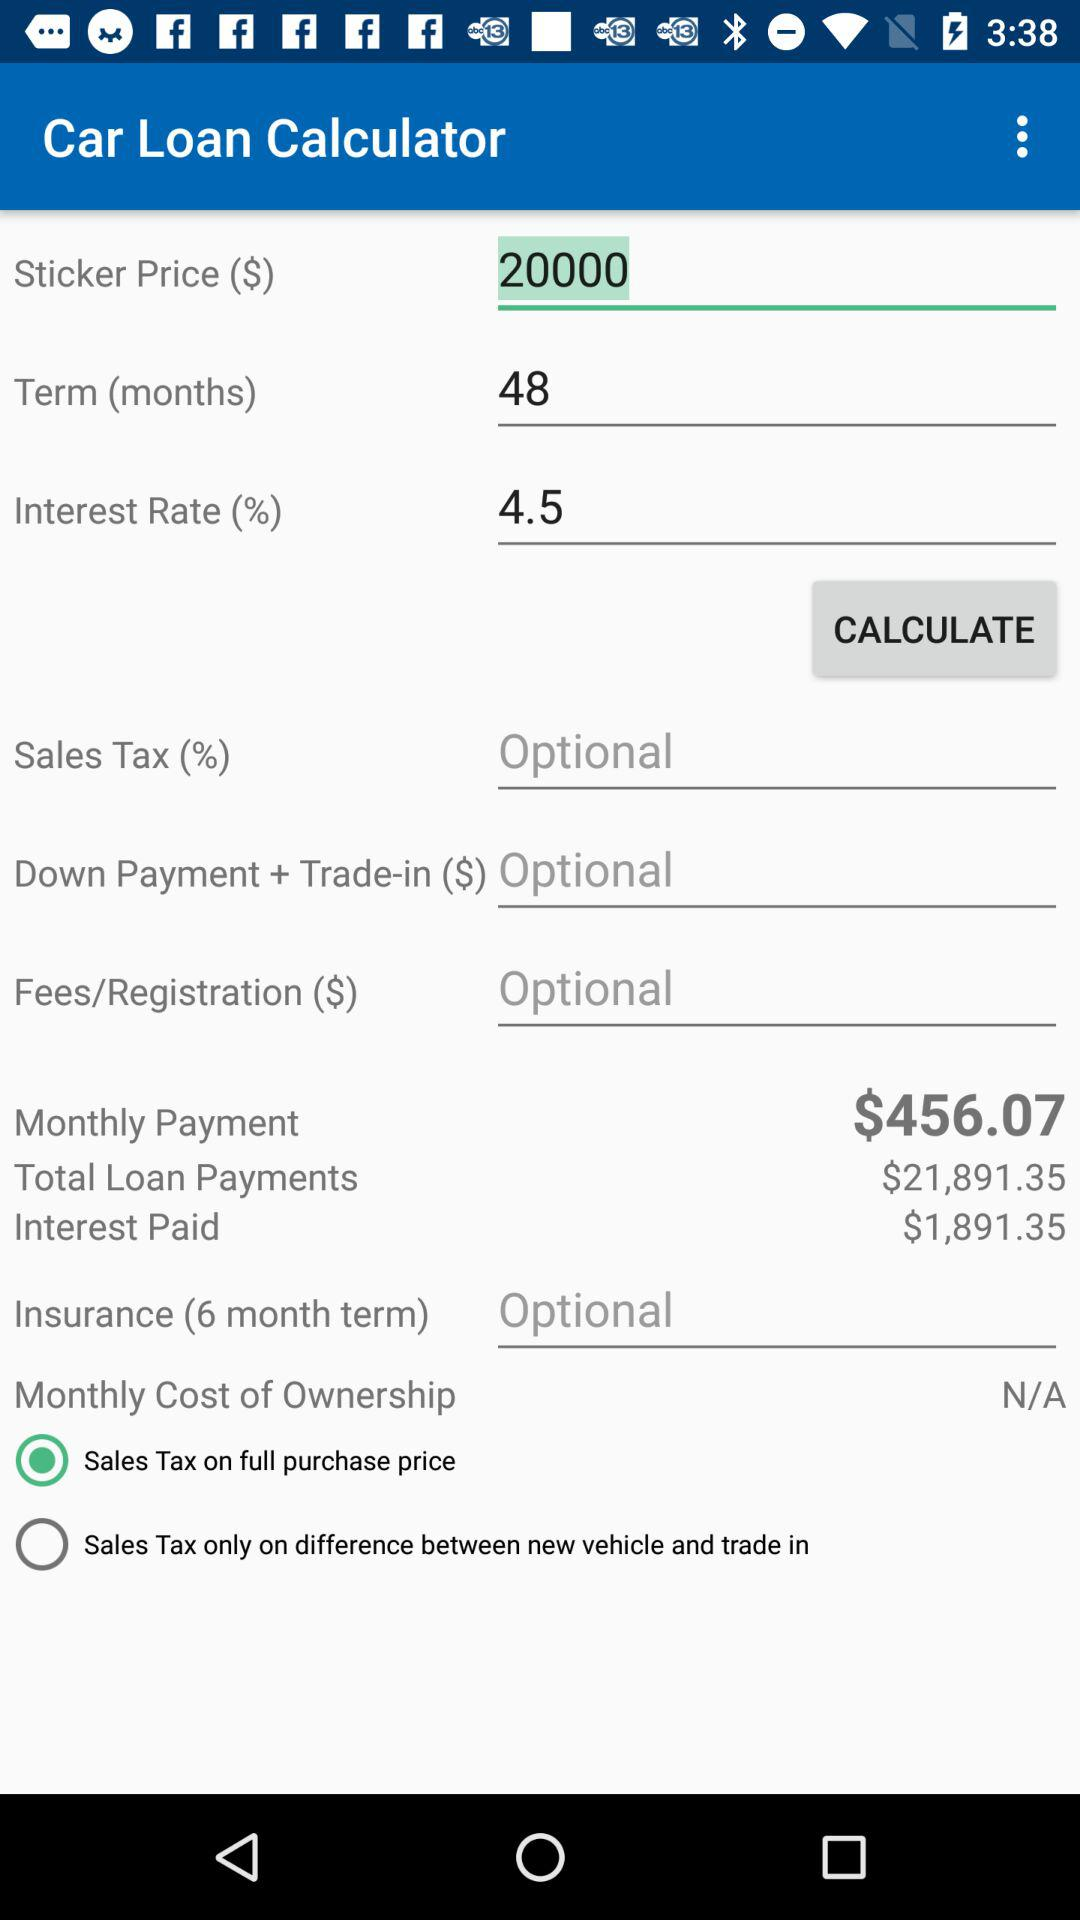What is the amount of interest paid? The amount is $1,891.35. 